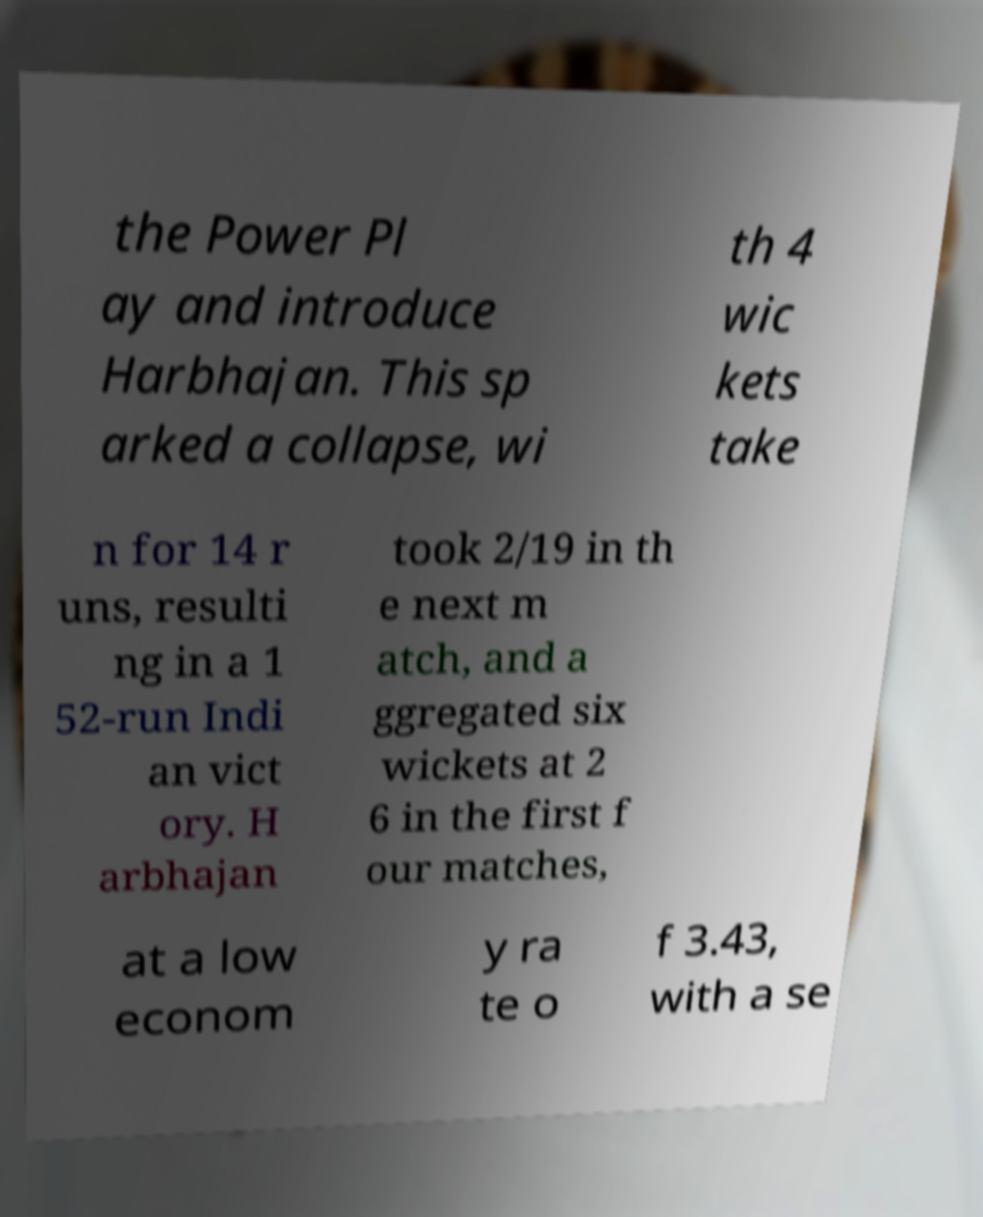Can you read and provide the text displayed in the image?This photo seems to have some interesting text. Can you extract and type it out for me? the Power Pl ay and introduce Harbhajan. This sp arked a collapse, wi th 4 wic kets take n for 14 r uns, resulti ng in a 1 52-run Indi an vict ory. H arbhajan took 2/19 in th e next m atch, and a ggregated six wickets at 2 6 in the first f our matches, at a low econom y ra te o f 3.43, with a se 